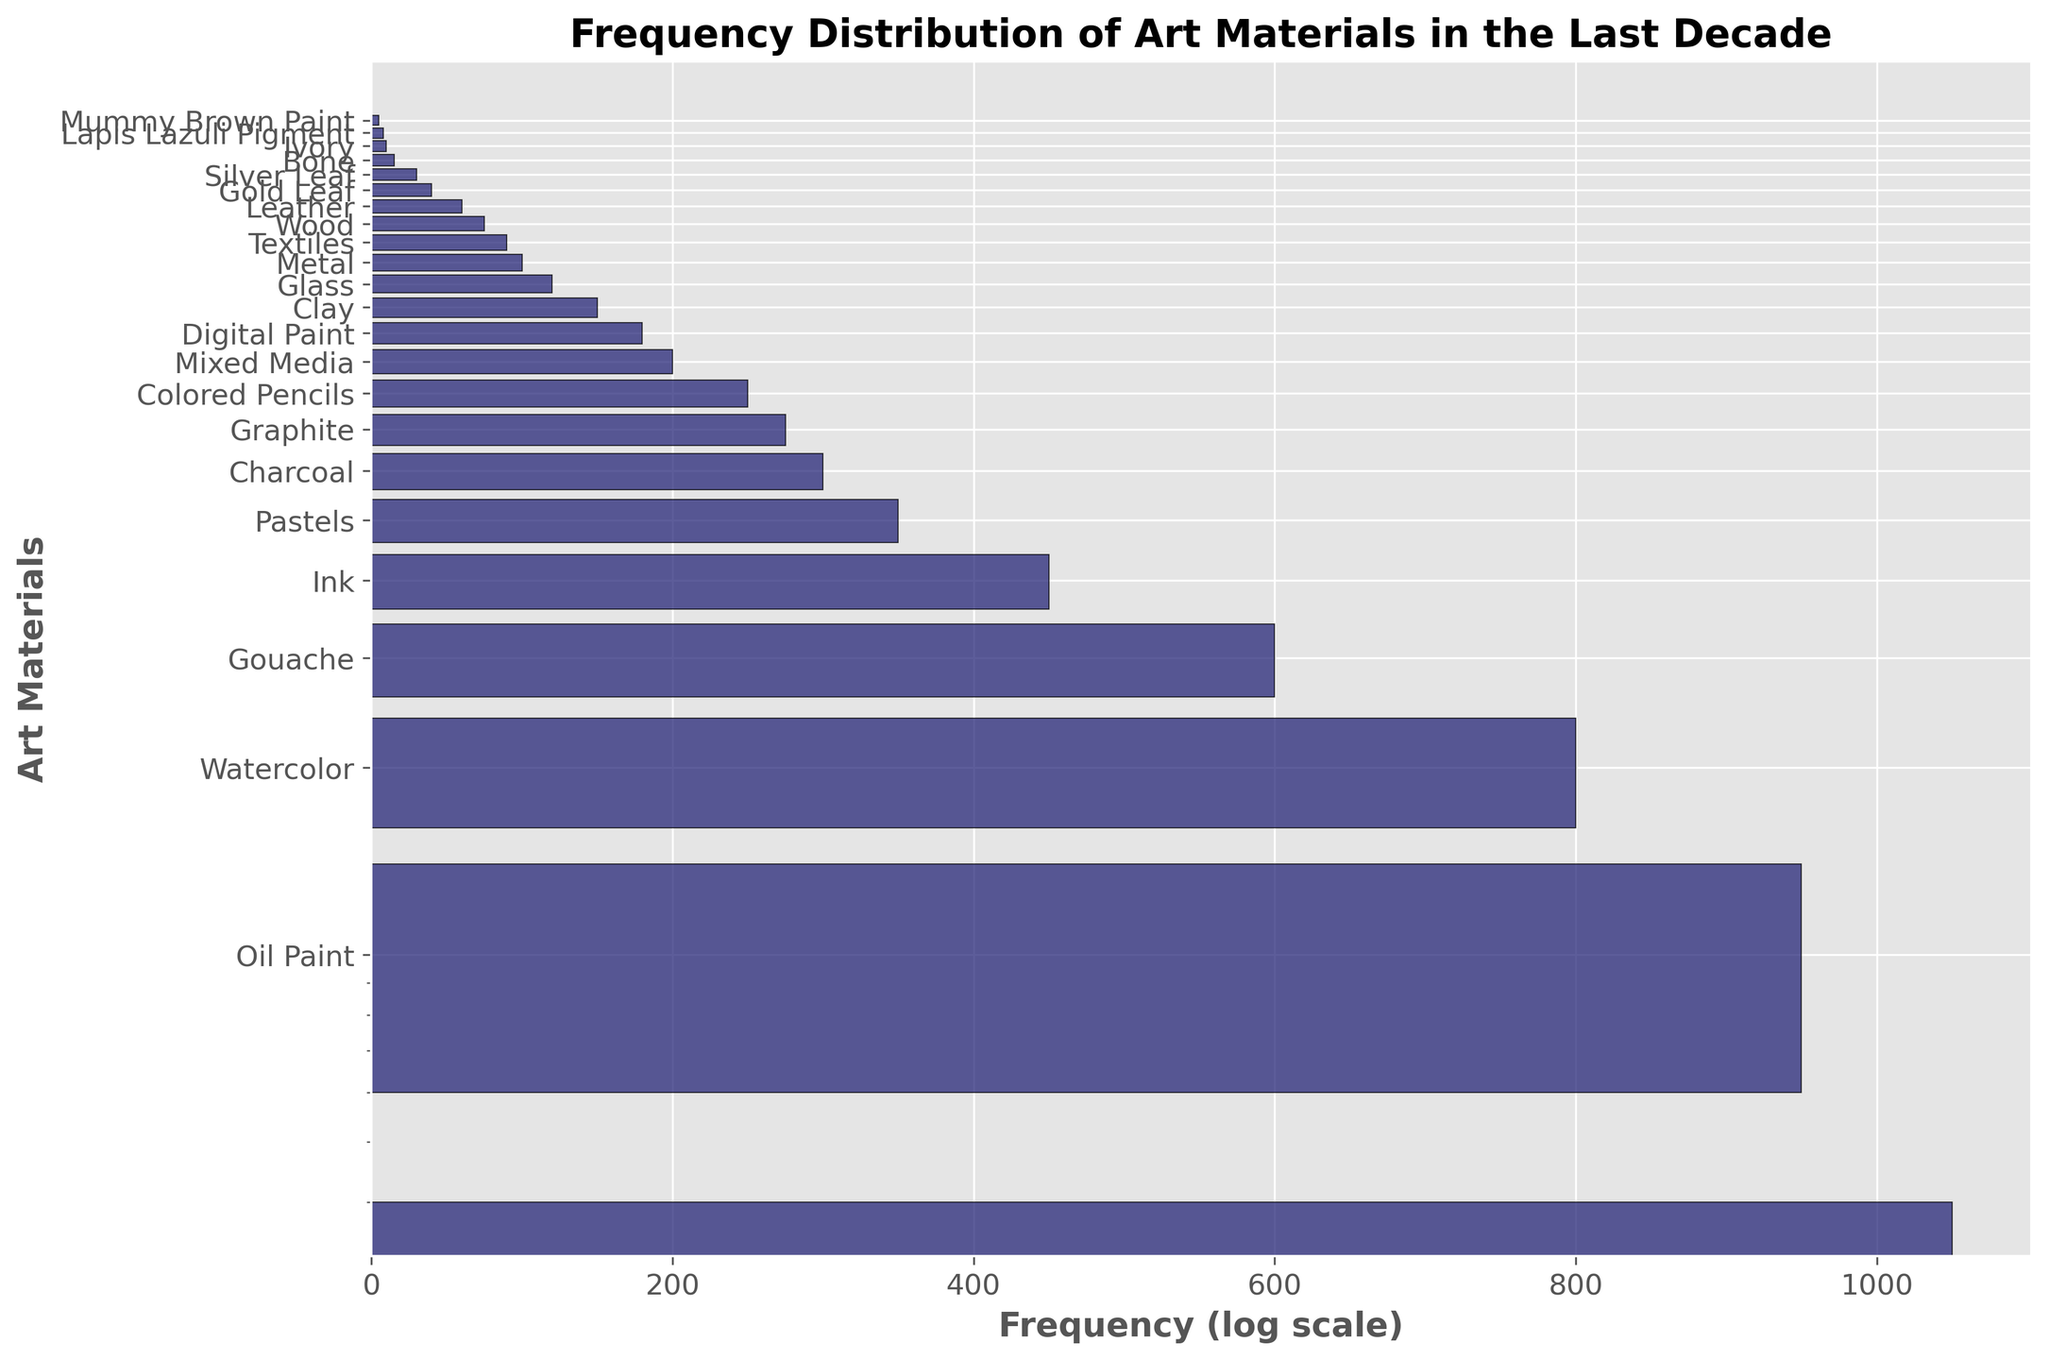Which art material is used the most frequently? The bar representing Acrylic Paint is the longest, indicating it has the highest frequency count on the chart.
Answer: Acrylic Paint Which art material is used the least frequently? The bar representing Mummy Brown Paint is the shortest, indicating it has the lowest frequency count on the chart.
Answer: Mummy Brown Paint How does the frequency of the least used material compare to the most used material? The frequency of Mummy Brown Paint (5) is much lower than the frequency of Acrylic Paint (1050).
Answer: Much lower What is the combined frequency of Gold Leaf and Silver Leaf usage? The frequency of Gold Leaf is 40, and Silver Leaf is 30. Their combined frequency is 40 + 30 = 70.
Answer: 70 Which materials have a frequency between 50 and 100? Based on the log-scale y-axis, Metal (100), Textiles (90), and Leather (60) fall between 50 and 100.
Answer: Metal, Textiles, Leather How many art materials have a frequency below 100? Art materials with frequencies below 100 are Textiles (90), Wood (75), Leather (60), Gold Leaf (40), Silver Leaf (30), Bone (15), Ivory (10), Lapis Lazuli Pigment (8), and Mummy Brown Paint (5). The total count is 9.
Answer: 9 Which art materials have a frequency higher than Digital Paint but lower than Mixed Media? Digital Paint has a frequency of 180, and Mixed Media is 200. No art materials fall within this range.
Answer: None How does the frequency of Watercolor compare to that of Ink? Watercolor has a frequency of 800, while Ink has 450. Watercolor is used more frequently than Ink.
Answer: Watercolor is more frequent What is the frequency difference between Charcoal and Graphite? The frequency of Charcoal is 300, and Graphite is 275. The difference is 300 - 275 = 25.
Answer: 25 Do any art materials have the same frequency? The chart shows that every art material has a unique frequency, and no two materials have the same frequency.
Answer: No 